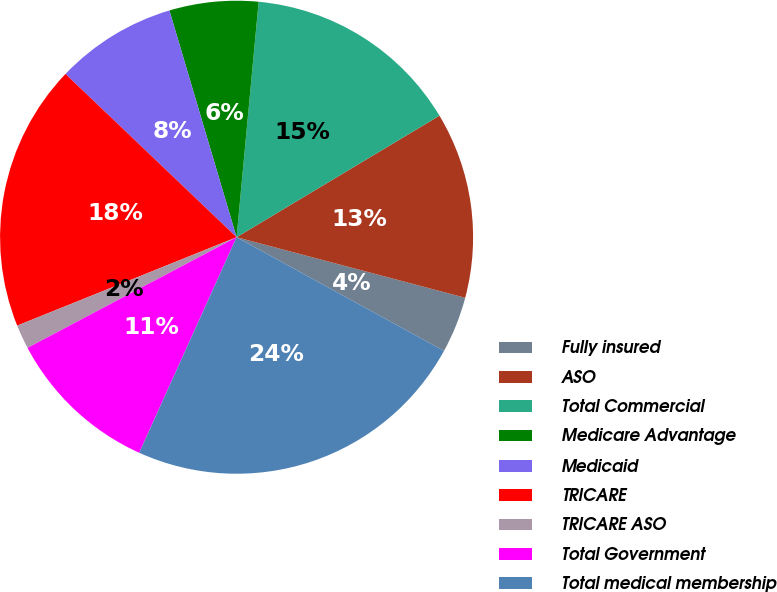Convert chart to OTSL. <chart><loc_0><loc_0><loc_500><loc_500><pie_chart><fcel>Fully insured<fcel>ASO<fcel>Total Commercial<fcel>Medicare Advantage<fcel>Medicaid<fcel>TRICARE<fcel>TRICARE ASO<fcel>Total Government<fcel>Total medical membership<nl><fcel>3.86%<fcel>12.71%<fcel>14.92%<fcel>6.07%<fcel>8.29%<fcel>18.22%<fcel>1.65%<fcel>10.5%<fcel>23.77%<nl></chart> 